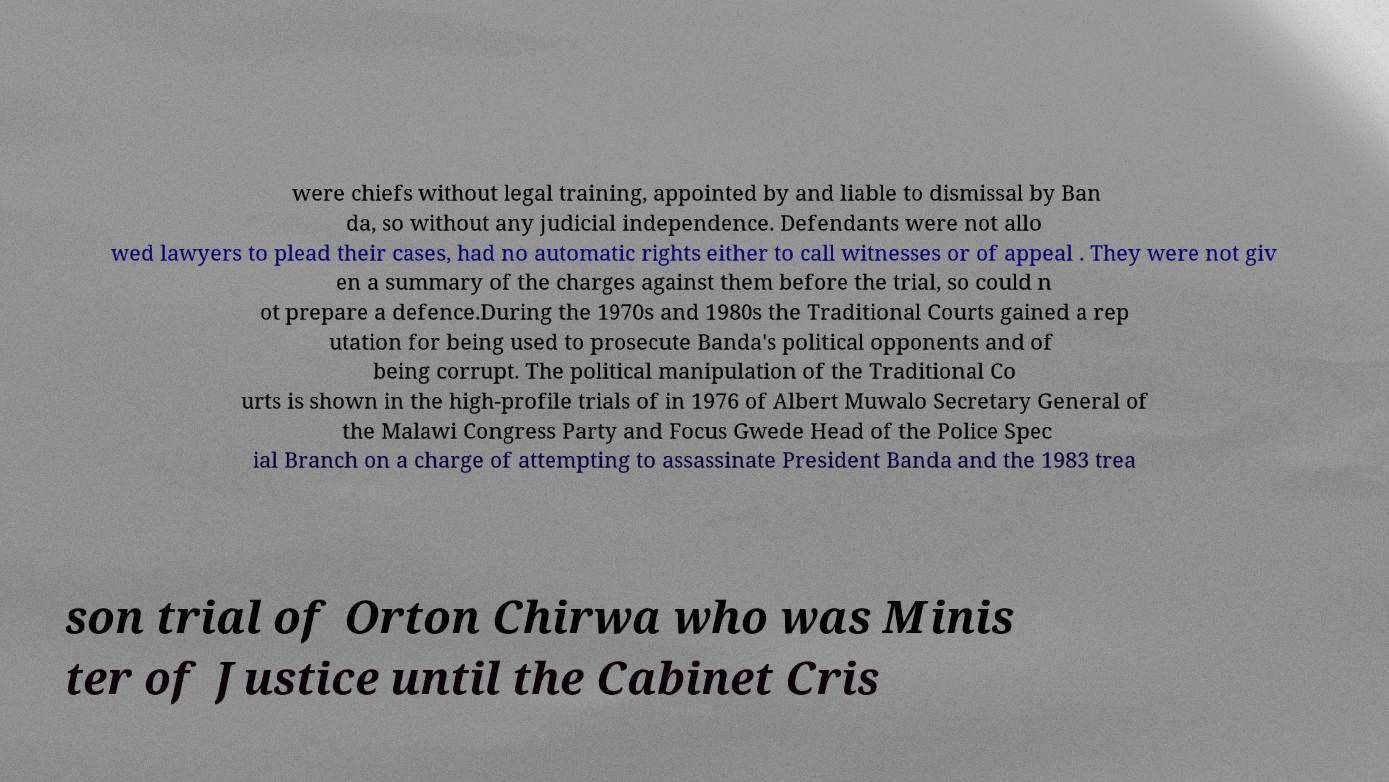Could you assist in decoding the text presented in this image and type it out clearly? were chiefs without legal training, appointed by and liable to dismissal by Ban da, so without any judicial independence. Defendants were not allo wed lawyers to plead their cases, had no automatic rights either to call witnesses or of appeal . They were not giv en a summary of the charges against them before the trial, so could n ot prepare a defence.During the 1970s and 1980s the Traditional Courts gained a rep utation for being used to prosecute Banda's political opponents and of being corrupt. The political manipulation of the Traditional Co urts is shown in the high-profile trials of in 1976 of Albert Muwalo Secretary General of the Malawi Congress Party and Focus Gwede Head of the Police Spec ial Branch on a charge of attempting to assassinate President Banda and the 1983 trea son trial of Orton Chirwa who was Minis ter of Justice until the Cabinet Cris 